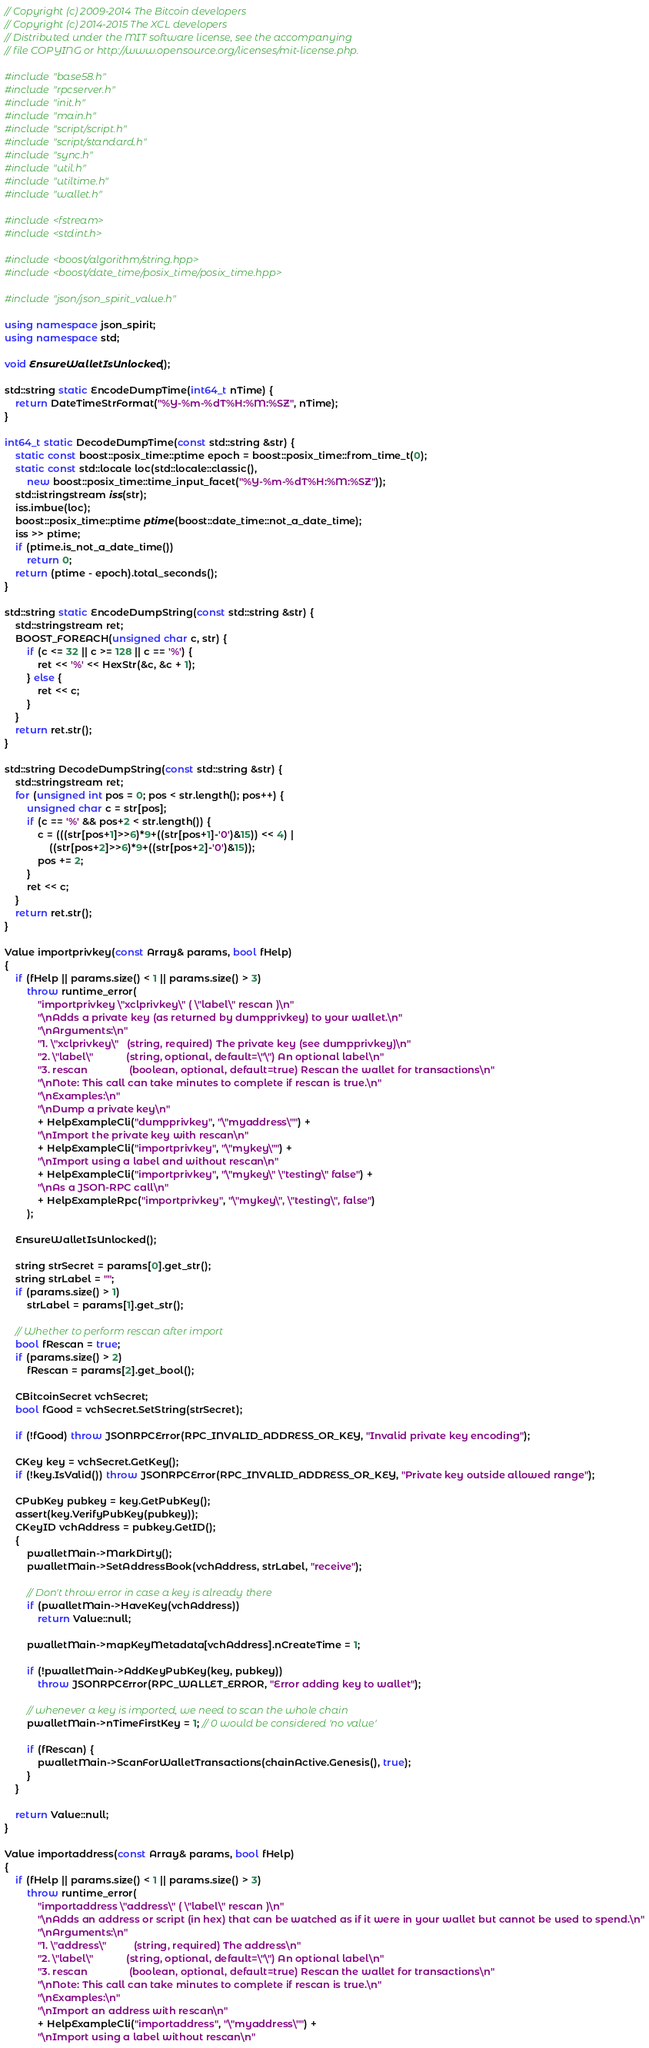Convert code to text. <code><loc_0><loc_0><loc_500><loc_500><_C++_>// Copyright (c) 2009-2014 The Bitcoin developers
// Copyright (c) 2014-2015 The XCL developers
// Distributed under the MIT software license, see the accompanying
// file COPYING or http://www.opensource.org/licenses/mit-license.php.

#include "base58.h"
#include "rpcserver.h"
#include "init.h"
#include "main.h"
#include "script/script.h"
#include "script/standard.h"
#include "sync.h"
#include "util.h"
#include "utiltime.h"
#include "wallet.h"

#include <fstream>
#include <stdint.h>

#include <boost/algorithm/string.hpp>
#include <boost/date_time/posix_time/posix_time.hpp>

#include "json/json_spirit_value.h"

using namespace json_spirit;
using namespace std;

void EnsureWalletIsUnlocked();

std::string static EncodeDumpTime(int64_t nTime) {
    return DateTimeStrFormat("%Y-%m-%dT%H:%M:%SZ", nTime);
}

int64_t static DecodeDumpTime(const std::string &str) {
    static const boost::posix_time::ptime epoch = boost::posix_time::from_time_t(0);
    static const std::locale loc(std::locale::classic(),
        new boost::posix_time::time_input_facet("%Y-%m-%dT%H:%M:%SZ"));
    std::istringstream iss(str);
    iss.imbue(loc);
    boost::posix_time::ptime ptime(boost::date_time::not_a_date_time);
    iss >> ptime;
    if (ptime.is_not_a_date_time())
        return 0;
    return (ptime - epoch).total_seconds();
}

std::string static EncodeDumpString(const std::string &str) {
    std::stringstream ret;
    BOOST_FOREACH(unsigned char c, str) {
        if (c <= 32 || c >= 128 || c == '%') {
            ret << '%' << HexStr(&c, &c + 1);
        } else {
            ret << c;
        }
    }
    return ret.str();
}

std::string DecodeDumpString(const std::string &str) {
    std::stringstream ret;
    for (unsigned int pos = 0; pos < str.length(); pos++) {
        unsigned char c = str[pos];
        if (c == '%' && pos+2 < str.length()) {
            c = (((str[pos+1]>>6)*9+((str[pos+1]-'0')&15)) << 4) |
                ((str[pos+2]>>6)*9+((str[pos+2]-'0')&15));
            pos += 2;
        }
        ret << c;
    }
    return ret.str();
}

Value importprivkey(const Array& params, bool fHelp)
{
    if (fHelp || params.size() < 1 || params.size() > 3)
        throw runtime_error(
            "importprivkey \"xclprivkey\" ( \"label\" rescan )\n"
            "\nAdds a private key (as returned by dumpprivkey) to your wallet.\n"
            "\nArguments:\n"
            "1. \"xclprivkey\"   (string, required) The private key (see dumpprivkey)\n"
            "2. \"label\"            (string, optional, default=\"\") An optional label\n"
            "3. rescan               (boolean, optional, default=true) Rescan the wallet for transactions\n"
            "\nNote: This call can take minutes to complete if rescan is true.\n"
            "\nExamples:\n"
            "\nDump a private key\n"
            + HelpExampleCli("dumpprivkey", "\"myaddress\"") +
            "\nImport the private key with rescan\n"
            + HelpExampleCli("importprivkey", "\"mykey\"") +
            "\nImport using a label and without rescan\n"
            + HelpExampleCli("importprivkey", "\"mykey\" \"testing\" false") +
            "\nAs a JSON-RPC call\n"
            + HelpExampleRpc("importprivkey", "\"mykey\", \"testing\", false")
        );

    EnsureWalletIsUnlocked();

    string strSecret = params[0].get_str();
    string strLabel = "";
    if (params.size() > 1)
        strLabel = params[1].get_str();

    // Whether to perform rescan after import
    bool fRescan = true;
    if (params.size() > 2)
        fRescan = params[2].get_bool();

    CBitcoinSecret vchSecret;
    bool fGood = vchSecret.SetString(strSecret);

    if (!fGood) throw JSONRPCError(RPC_INVALID_ADDRESS_OR_KEY, "Invalid private key encoding");

    CKey key = vchSecret.GetKey();
    if (!key.IsValid()) throw JSONRPCError(RPC_INVALID_ADDRESS_OR_KEY, "Private key outside allowed range");

    CPubKey pubkey = key.GetPubKey();
    assert(key.VerifyPubKey(pubkey));
    CKeyID vchAddress = pubkey.GetID();
    {
        pwalletMain->MarkDirty();
        pwalletMain->SetAddressBook(vchAddress, strLabel, "receive");

        // Don't throw error in case a key is already there
        if (pwalletMain->HaveKey(vchAddress))
            return Value::null;

        pwalletMain->mapKeyMetadata[vchAddress].nCreateTime = 1;

        if (!pwalletMain->AddKeyPubKey(key, pubkey))
            throw JSONRPCError(RPC_WALLET_ERROR, "Error adding key to wallet");

        // whenever a key is imported, we need to scan the whole chain
        pwalletMain->nTimeFirstKey = 1; // 0 would be considered 'no value'

        if (fRescan) {
            pwalletMain->ScanForWalletTransactions(chainActive.Genesis(), true);
        }
    }

    return Value::null;
}

Value importaddress(const Array& params, bool fHelp)
{
    if (fHelp || params.size() < 1 || params.size() > 3)
        throw runtime_error(
            "importaddress \"address\" ( \"label\" rescan )\n"
            "\nAdds an address or script (in hex) that can be watched as if it were in your wallet but cannot be used to spend.\n"
            "\nArguments:\n"
            "1. \"address\"          (string, required) The address\n"
            "2. \"label\"            (string, optional, default=\"\") An optional label\n"
            "3. rescan               (boolean, optional, default=true) Rescan the wallet for transactions\n"
            "\nNote: This call can take minutes to complete if rescan is true.\n"
            "\nExamples:\n"
            "\nImport an address with rescan\n"
            + HelpExampleCli("importaddress", "\"myaddress\"") +
            "\nImport using a label without rescan\n"</code> 